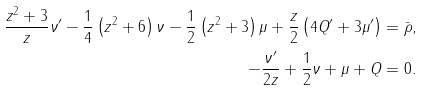<formula> <loc_0><loc_0><loc_500><loc_500>\frac { z ^ { 2 } + 3 } { z } \nu ^ { \prime } - \frac { 1 } { 4 } \left ( z ^ { 2 } + 6 \right ) \nu - \frac { 1 } { 2 } \left ( z ^ { 2 } + 3 \right ) \mu + \frac { z } { 2 } \left ( 4 Q ^ { \prime } + 3 \mu ^ { \prime } \right ) & = \bar { \rho } , \\ - \frac { \nu ^ { \prime } } { 2 z } + \frac { 1 } { 2 } \nu + \mu + Q & = 0 .</formula> 